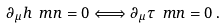<formula> <loc_0><loc_0><loc_500><loc_500>\partial _ { \mu } h \ m n = 0 \Longleftrightarrow \partial _ { \mu } \tau \ m n = 0 \, .</formula> 